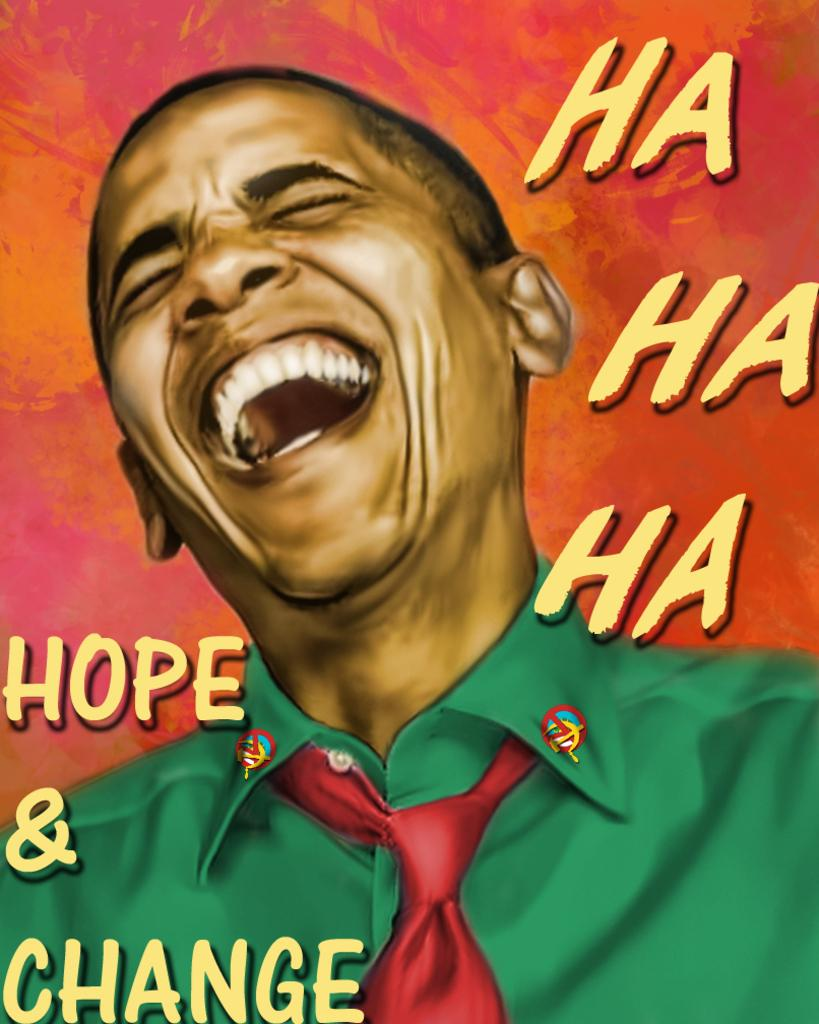What is the main subject of the image? The main subject of the image is a painting on a poster. What is the person in the painting doing? The person in the painting is laughing. What else can be seen on the poster besides the painting? There are letters on the poster. What colors are used in the background of the poster? The background of the poster has orange and pink colors. What type of snails can be seen crawling on the person's face in the image? There are no snails present in the image; it features a painting of a person laughing with no visible snails. 